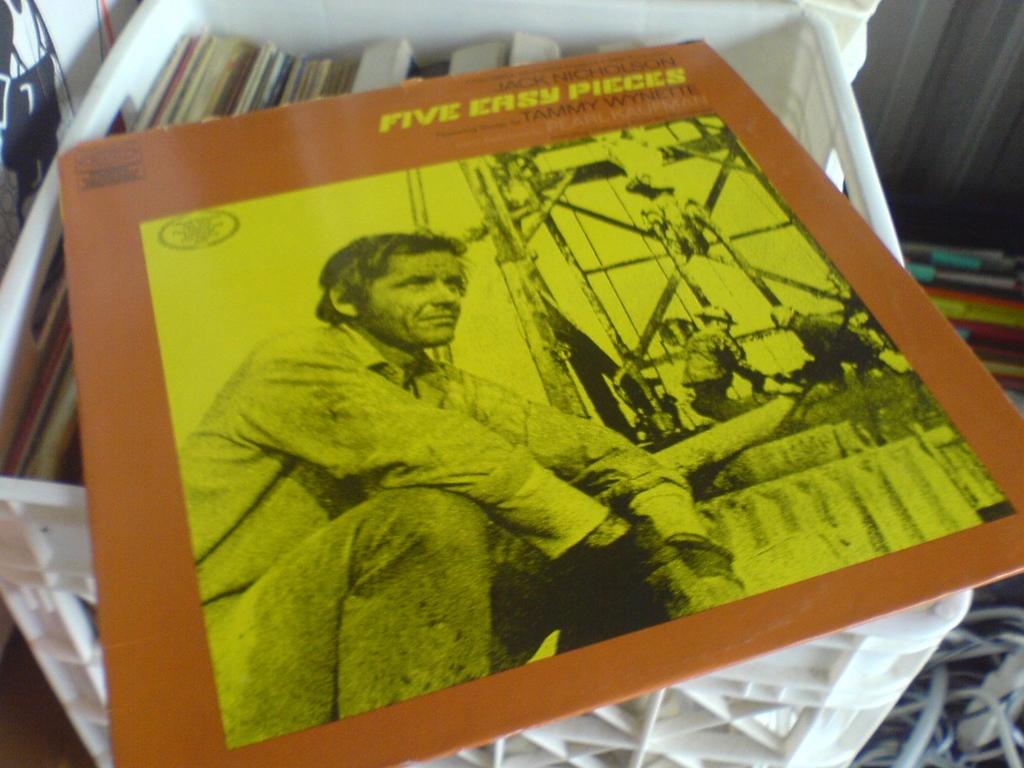What is the title of the record?
Provide a short and direct response. Five easy pieces. What is the name of one of the artists?
Ensure brevity in your answer.  Tammy wynette. 